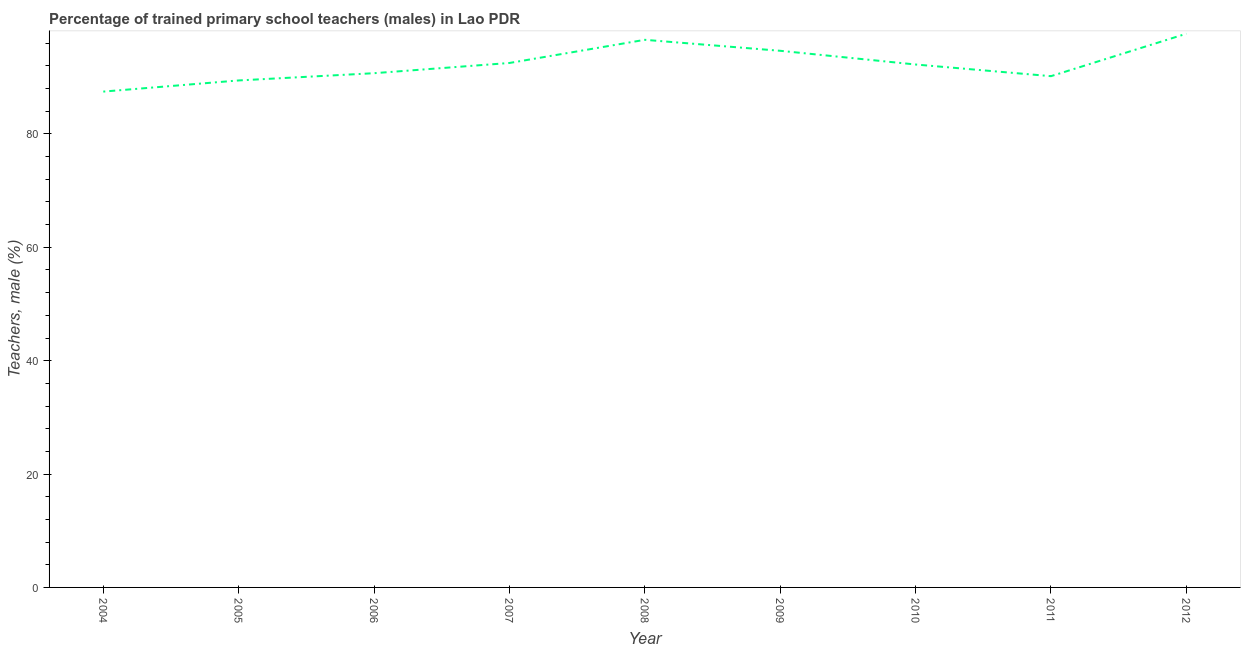What is the percentage of trained male teachers in 2011?
Keep it short and to the point. 90.19. Across all years, what is the maximum percentage of trained male teachers?
Make the answer very short. 97.68. Across all years, what is the minimum percentage of trained male teachers?
Keep it short and to the point. 87.47. What is the sum of the percentage of trained male teachers?
Your answer should be compact. 831.55. What is the difference between the percentage of trained male teachers in 2006 and 2008?
Your answer should be very brief. -5.89. What is the average percentage of trained male teachers per year?
Your answer should be compact. 92.39. What is the median percentage of trained male teachers?
Give a very brief answer. 92.25. What is the ratio of the percentage of trained male teachers in 2004 to that in 2012?
Offer a very short reply. 0.9. Is the difference between the percentage of trained male teachers in 2004 and 2009 greater than the difference between any two years?
Provide a succinct answer. No. What is the difference between the highest and the second highest percentage of trained male teachers?
Your answer should be very brief. 1.08. Is the sum of the percentage of trained male teachers in 2004 and 2010 greater than the maximum percentage of trained male teachers across all years?
Your response must be concise. Yes. What is the difference between the highest and the lowest percentage of trained male teachers?
Provide a succinct answer. 10.21. Does the percentage of trained male teachers monotonically increase over the years?
Provide a succinct answer. No. How many years are there in the graph?
Offer a terse response. 9. What is the difference between two consecutive major ticks on the Y-axis?
Make the answer very short. 20. Does the graph contain grids?
Give a very brief answer. No. What is the title of the graph?
Make the answer very short. Percentage of trained primary school teachers (males) in Lao PDR. What is the label or title of the X-axis?
Offer a terse response. Year. What is the label or title of the Y-axis?
Your answer should be very brief. Teachers, male (%). What is the Teachers, male (%) of 2004?
Your response must be concise. 87.47. What is the Teachers, male (%) of 2005?
Keep it short and to the point. 89.44. What is the Teachers, male (%) of 2006?
Give a very brief answer. 90.72. What is the Teachers, male (%) of 2007?
Provide a short and direct response. 92.52. What is the Teachers, male (%) in 2008?
Offer a very short reply. 96.61. What is the Teachers, male (%) of 2009?
Offer a terse response. 94.67. What is the Teachers, male (%) in 2010?
Your answer should be compact. 92.25. What is the Teachers, male (%) in 2011?
Your answer should be compact. 90.19. What is the Teachers, male (%) of 2012?
Give a very brief answer. 97.68. What is the difference between the Teachers, male (%) in 2004 and 2005?
Keep it short and to the point. -1.97. What is the difference between the Teachers, male (%) in 2004 and 2006?
Keep it short and to the point. -3.25. What is the difference between the Teachers, male (%) in 2004 and 2007?
Offer a very short reply. -5.05. What is the difference between the Teachers, male (%) in 2004 and 2008?
Offer a very short reply. -9.13. What is the difference between the Teachers, male (%) in 2004 and 2009?
Make the answer very short. -7.2. What is the difference between the Teachers, male (%) in 2004 and 2010?
Make the answer very short. -4.78. What is the difference between the Teachers, male (%) in 2004 and 2011?
Offer a terse response. -2.72. What is the difference between the Teachers, male (%) in 2004 and 2012?
Your answer should be very brief. -10.21. What is the difference between the Teachers, male (%) in 2005 and 2006?
Provide a short and direct response. -1.28. What is the difference between the Teachers, male (%) in 2005 and 2007?
Provide a short and direct response. -3.08. What is the difference between the Teachers, male (%) in 2005 and 2008?
Ensure brevity in your answer.  -7.17. What is the difference between the Teachers, male (%) in 2005 and 2009?
Ensure brevity in your answer.  -5.23. What is the difference between the Teachers, male (%) in 2005 and 2010?
Provide a short and direct response. -2.81. What is the difference between the Teachers, male (%) in 2005 and 2011?
Offer a terse response. -0.75. What is the difference between the Teachers, male (%) in 2005 and 2012?
Offer a very short reply. -8.24. What is the difference between the Teachers, male (%) in 2006 and 2007?
Your answer should be compact. -1.8. What is the difference between the Teachers, male (%) in 2006 and 2008?
Provide a short and direct response. -5.89. What is the difference between the Teachers, male (%) in 2006 and 2009?
Your response must be concise. -3.95. What is the difference between the Teachers, male (%) in 2006 and 2010?
Ensure brevity in your answer.  -1.53. What is the difference between the Teachers, male (%) in 2006 and 2011?
Your response must be concise. 0.53. What is the difference between the Teachers, male (%) in 2006 and 2012?
Your answer should be compact. -6.96. What is the difference between the Teachers, male (%) in 2007 and 2008?
Offer a terse response. -4.09. What is the difference between the Teachers, male (%) in 2007 and 2009?
Offer a terse response. -2.15. What is the difference between the Teachers, male (%) in 2007 and 2010?
Provide a short and direct response. 0.27. What is the difference between the Teachers, male (%) in 2007 and 2011?
Provide a short and direct response. 2.33. What is the difference between the Teachers, male (%) in 2007 and 2012?
Offer a terse response. -5.16. What is the difference between the Teachers, male (%) in 2008 and 2009?
Make the answer very short. 1.94. What is the difference between the Teachers, male (%) in 2008 and 2010?
Your answer should be very brief. 4.35. What is the difference between the Teachers, male (%) in 2008 and 2011?
Your response must be concise. 6.41. What is the difference between the Teachers, male (%) in 2008 and 2012?
Keep it short and to the point. -1.08. What is the difference between the Teachers, male (%) in 2009 and 2010?
Give a very brief answer. 2.42. What is the difference between the Teachers, male (%) in 2009 and 2011?
Offer a very short reply. 4.48. What is the difference between the Teachers, male (%) in 2009 and 2012?
Make the answer very short. -3.01. What is the difference between the Teachers, male (%) in 2010 and 2011?
Your response must be concise. 2.06. What is the difference between the Teachers, male (%) in 2010 and 2012?
Provide a succinct answer. -5.43. What is the difference between the Teachers, male (%) in 2011 and 2012?
Offer a very short reply. -7.49. What is the ratio of the Teachers, male (%) in 2004 to that in 2007?
Offer a very short reply. 0.94. What is the ratio of the Teachers, male (%) in 2004 to that in 2008?
Provide a succinct answer. 0.91. What is the ratio of the Teachers, male (%) in 2004 to that in 2009?
Keep it short and to the point. 0.92. What is the ratio of the Teachers, male (%) in 2004 to that in 2010?
Your response must be concise. 0.95. What is the ratio of the Teachers, male (%) in 2004 to that in 2011?
Your answer should be very brief. 0.97. What is the ratio of the Teachers, male (%) in 2004 to that in 2012?
Offer a terse response. 0.9. What is the ratio of the Teachers, male (%) in 2005 to that in 2006?
Your answer should be compact. 0.99. What is the ratio of the Teachers, male (%) in 2005 to that in 2008?
Give a very brief answer. 0.93. What is the ratio of the Teachers, male (%) in 2005 to that in 2009?
Keep it short and to the point. 0.94. What is the ratio of the Teachers, male (%) in 2005 to that in 2011?
Your answer should be very brief. 0.99. What is the ratio of the Teachers, male (%) in 2005 to that in 2012?
Provide a short and direct response. 0.92. What is the ratio of the Teachers, male (%) in 2006 to that in 2007?
Your response must be concise. 0.98. What is the ratio of the Teachers, male (%) in 2006 to that in 2008?
Give a very brief answer. 0.94. What is the ratio of the Teachers, male (%) in 2006 to that in 2009?
Your answer should be very brief. 0.96. What is the ratio of the Teachers, male (%) in 2006 to that in 2010?
Provide a succinct answer. 0.98. What is the ratio of the Teachers, male (%) in 2006 to that in 2011?
Keep it short and to the point. 1.01. What is the ratio of the Teachers, male (%) in 2006 to that in 2012?
Provide a succinct answer. 0.93. What is the ratio of the Teachers, male (%) in 2007 to that in 2008?
Provide a short and direct response. 0.96. What is the ratio of the Teachers, male (%) in 2007 to that in 2009?
Offer a terse response. 0.98. What is the ratio of the Teachers, male (%) in 2007 to that in 2012?
Give a very brief answer. 0.95. What is the ratio of the Teachers, male (%) in 2008 to that in 2009?
Offer a very short reply. 1.02. What is the ratio of the Teachers, male (%) in 2008 to that in 2010?
Your response must be concise. 1.05. What is the ratio of the Teachers, male (%) in 2008 to that in 2011?
Your response must be concise. 1.07. What is the ratio of the Teachers, male (%) in 2010 to that in 2012?
Offer a very short reply. 0.94. What is the ratio of the Teachers, male (%) in 2011 to that in 2012?
Offer a terse response. 0.92. 